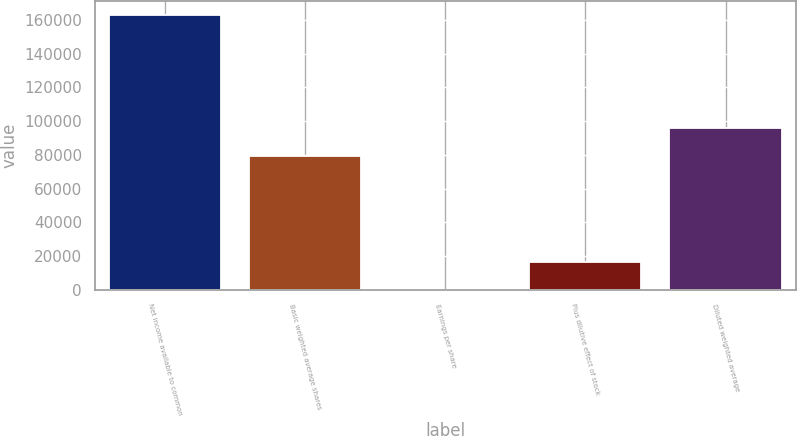<chart> <loc_0><loc_0><loc_500><loc_500><bar_chart><fcel>Net income available to common<fcel>Basic weighted average shares<fcel>Earnings per share<fcel>Plus dilutive effect of stock<fcel>Diluted weighted average<nl><fcel>162754<fcel>79518<fcel>2.05<fcel>16277.2<fcel>95793.2<nl></chart> 